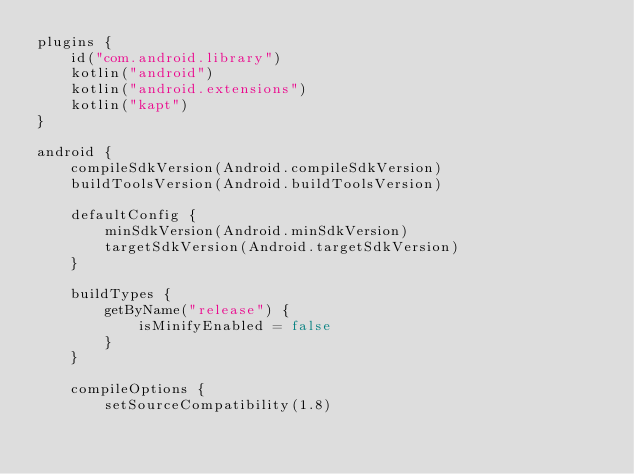<code> <loc_0><loc_0><loc_500><loc_500><_Kotlin_>plugins {
    id("com.android.library")
    kotlin("android")
    kotlin("android.extensions")
    kotlin("kapt")
}

android {
    compileSdkVersion(Android.compileSdkVersion)
    buildToolsVersion(Android.buildToolsVersion)

    defaultConfig {
        minSdkVersion(Android.minSdkVersion)
        targetSdkVersion(Android.targetSdkVersion)
    }

    buildTypes {
        getByName("release") {
            isMinifyEnabled = false
        }
    }

    compileOptions {
        setSourceCompatibility(1.8)</code> 